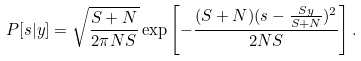Convert formula to latex. <formula><loc_0><loc_0><loc_500><loc_500>P [ s | y ] = \sqrt { \frac { S + N } { 2 \pi N S } } \exp \left [ - \frac { ( S + N ) ( s - \frac { S y } { S + N } ) ^ { 2 } } { 2 N S } \right ] .</formula> 